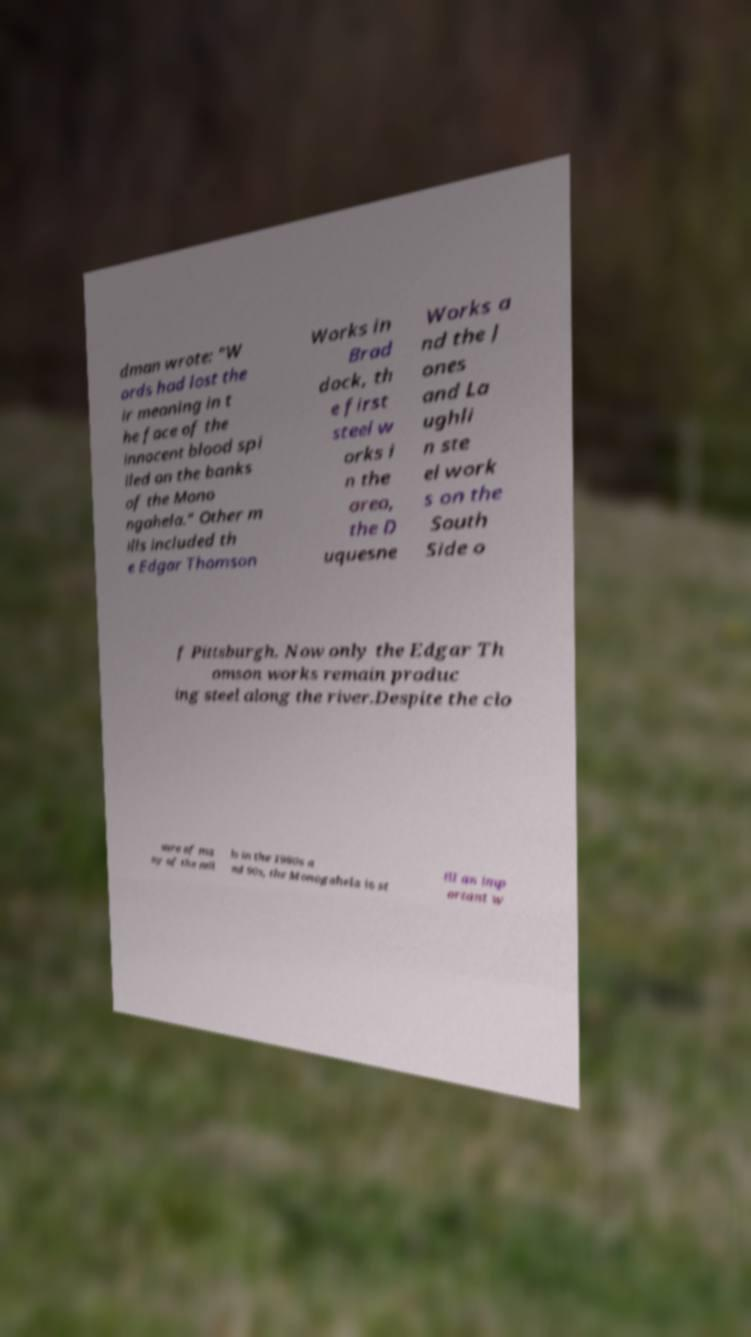Can you accurately transcribe the text from the provided image for me? dman wrote: "W ords had lost the ir meaning in t he face of the innocent blood spi lled on the banks of the Mono ngahela." Other m ills included th e Edgar Thomson Works in Brad dock, th e first steel w orks i n the area, the D uquesne Works a nd the J ones and La ughli n ste el work s on the South Side o f Pittsburgh. Now only the Edgar Th omson works remain produc ing steel along the river.Despite the clo sure of ma ny of the mil ls in the 1980s a nd 90s, the Monogahela is st ill an imp ortant w 